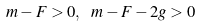<formula> <loc_0><loc_0><loc_500><loc_500>m - F > 0 , \ m - F - 2 g > 0</formula> 